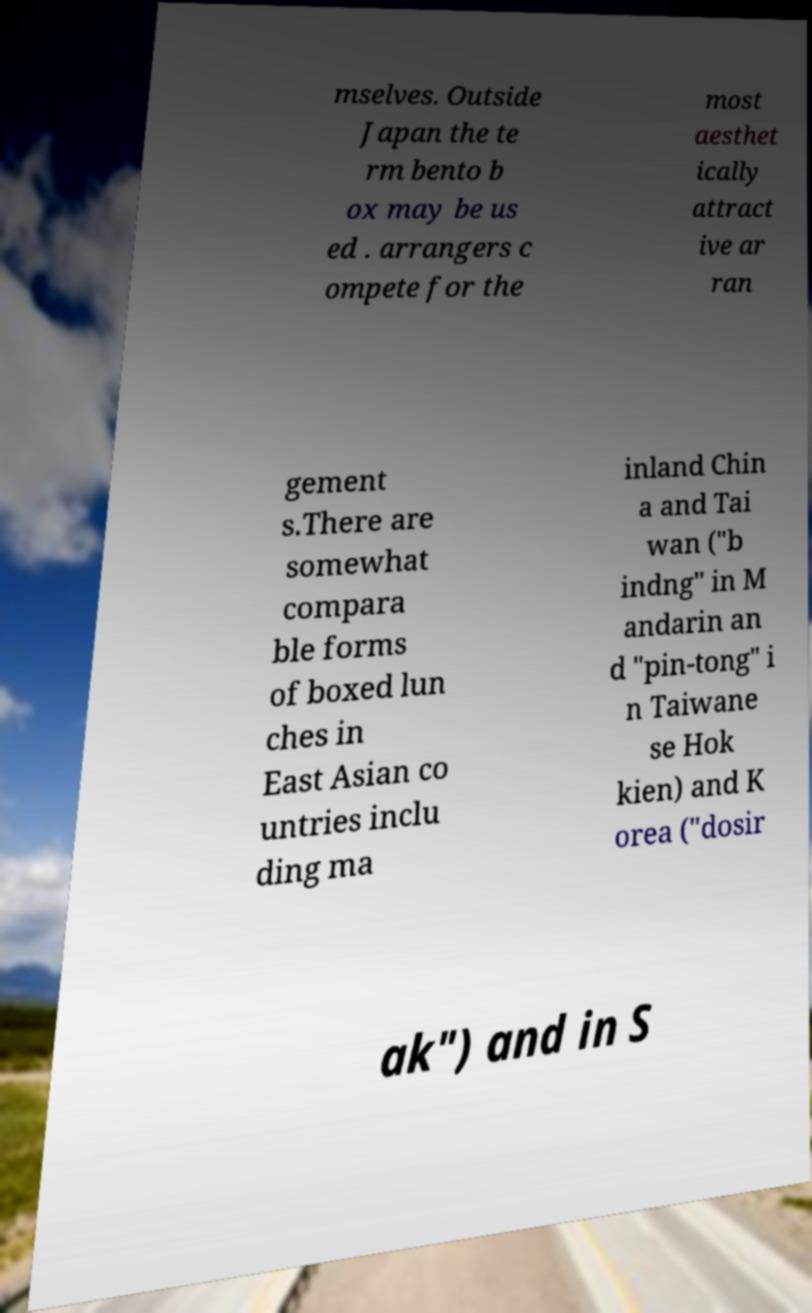Can you accurately transcribe the text from the provided image for me? mselves. Outside Japan the te rm bento b ox may be us ed . arrangers c ompete for the most aesthet ically attract ive ar ran gement s.There are somewhat compara ble forms of boxed lun ches in East Asian co untries inclu ding ma inland Chin a and Tai wan ("b indng" in M andarin an d "pin-tong" i n Taiwane se Hok kien) and K orea ("dosir ak") and in S 